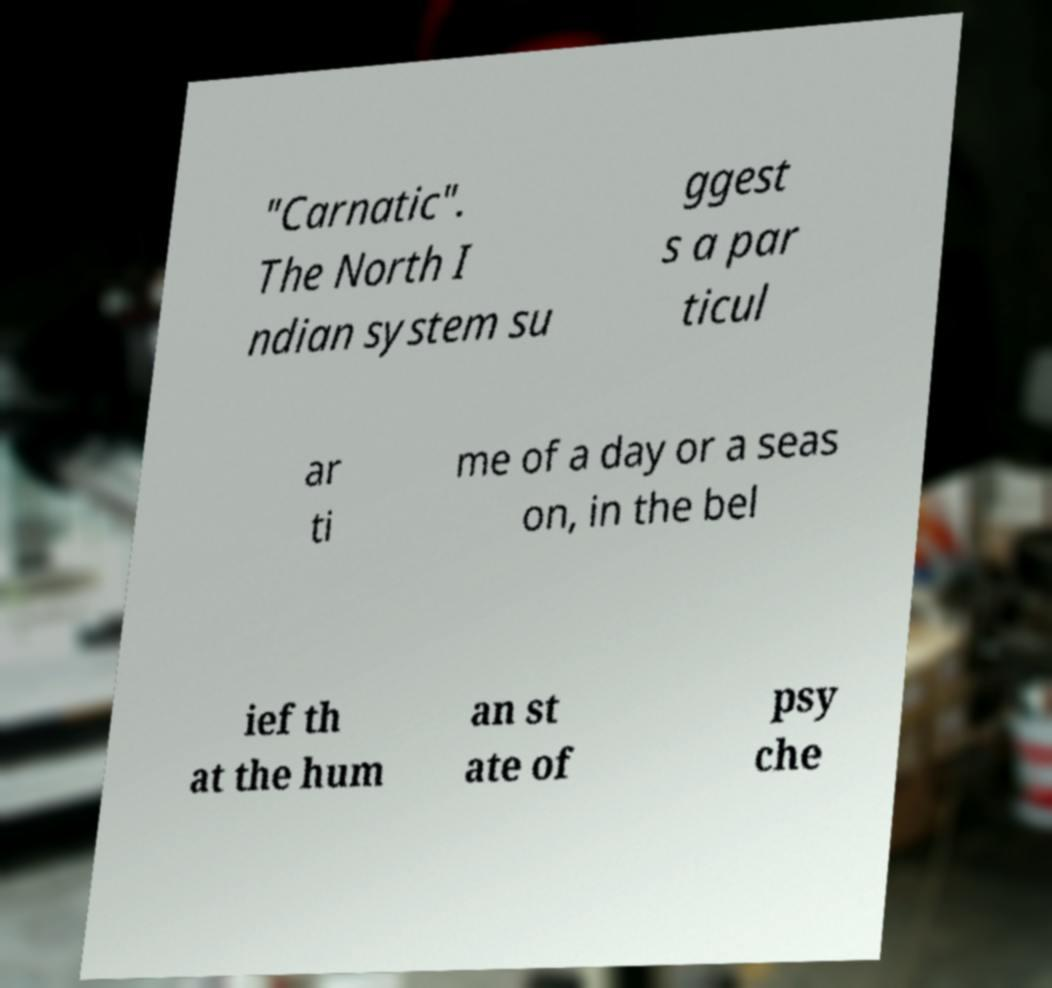Please identify and transcribe the text found in this image. "Carnatic". The North I ndian system su ggest s a par ticul ar ti me of a day or a seas on, in the bel ief th at the hum an st ate of psy che 